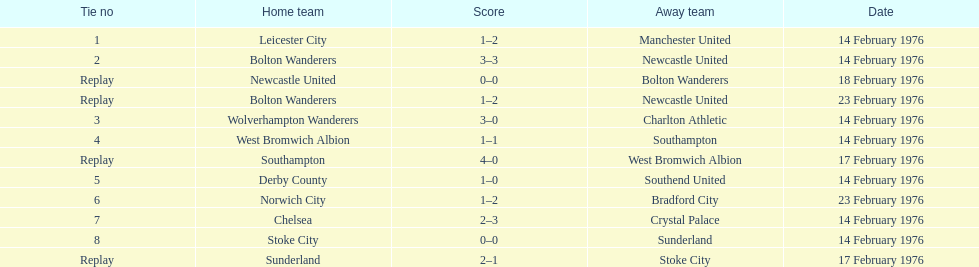How many teams took part on february 14th, 1976? 7. 